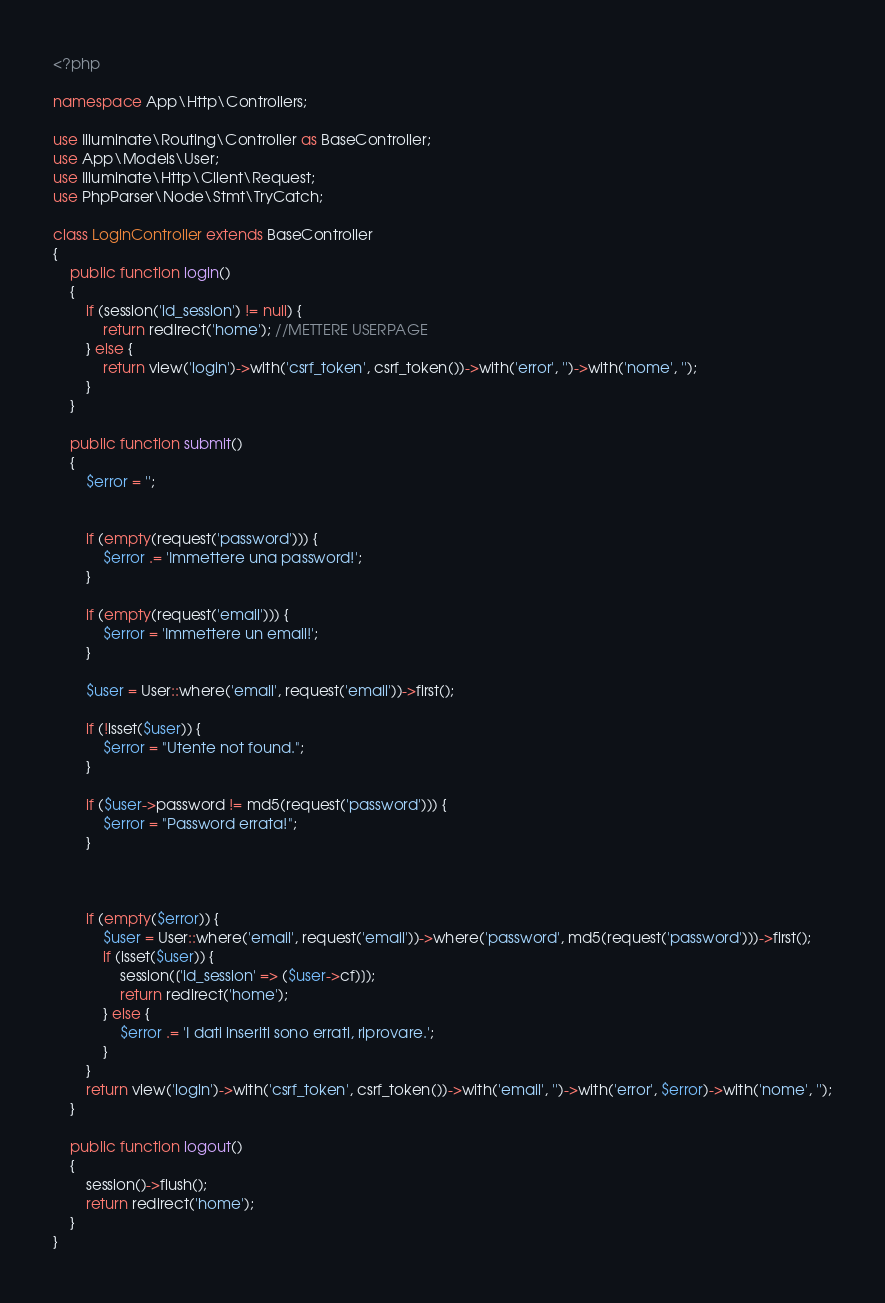<code> <loc_0><loc_0><loc_500><loc_500><_PHP_><?php

namespace App\Http\Controllers;

use Illuminate\Routing\Controller as BaseController;
use App\Models\User;
use Illuminate\Http\Client\Request;
use PhpParser\Node\Stmt\TryCatch;

class LoginController extends BaseController
{
    public function login()
    {
        if (session('id_session') != null) {
            return redirect('home'); //METTERE USERPAGE
        } else {
            return view('login')->with('csrf_token', csrf_token())->with('error', '')->with('nome', '');
        }
    }

    public function submit()
    {
        $error = '';


        if (empty(request('password'))) {
            $error .= 'Immettere una password!';
        }

        if (empty(request('email'))) {
            $error = 'Immettere un email!';
        }

        $user = User::where('email', request('email'))->first();

        if (!isset($user)) {
            $error = "Utente not found.";
        }

        if ($user->password != md5(request('password'))) {
            $error = "Password errata!";
        }



        if (empty($error)) {
            $user = User::where('email', request('email'))->where('password', md5(request('password')))->first();
            if (isset($user)) {
                session(['id_session' => ($user->cf)]);
                return redirect('home');
            } else {
                $error .= 'I dati inseriti sono errati, riprovare.';
            }
        }
        return view('login')->with('csrf_token', csrf_token())->with('email', '')->with('error', $error)->with('nome', '');
    }

    public function logout()
    {
        session()->flush();
        return redirect('home');
    }
}
</code> 